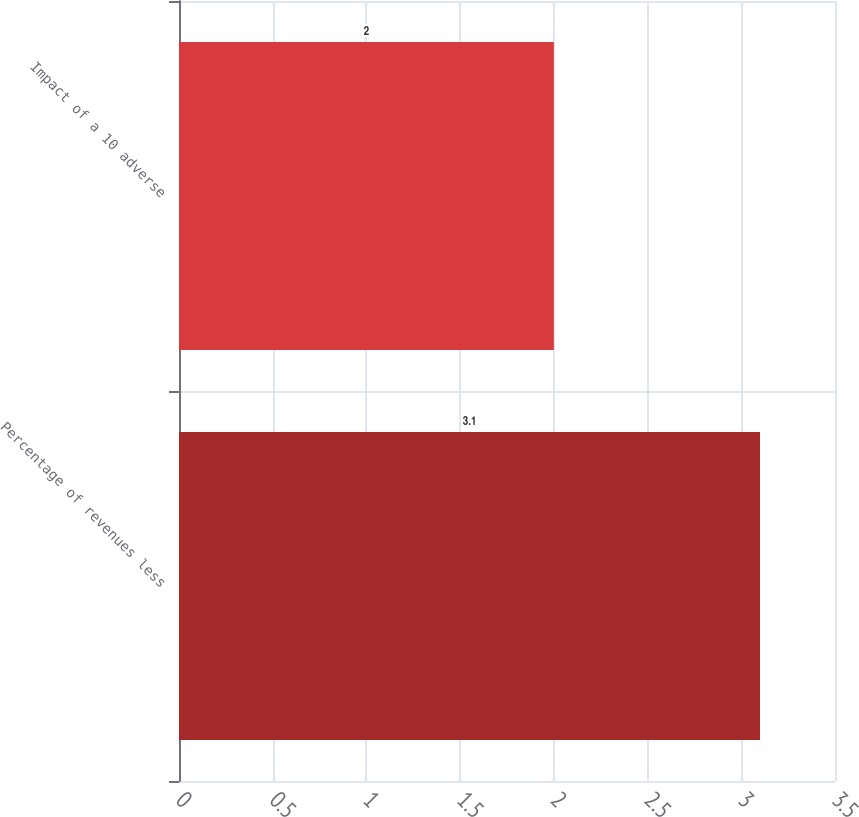Convert chart. <chart><loc_0><loc_0><loc_500><loc_500><bar_chart><fcel>Percentage of revenues less<fcel>Impact of a 10 adverse<nl><fcel>3.1<fcel>2<nl></chart> 